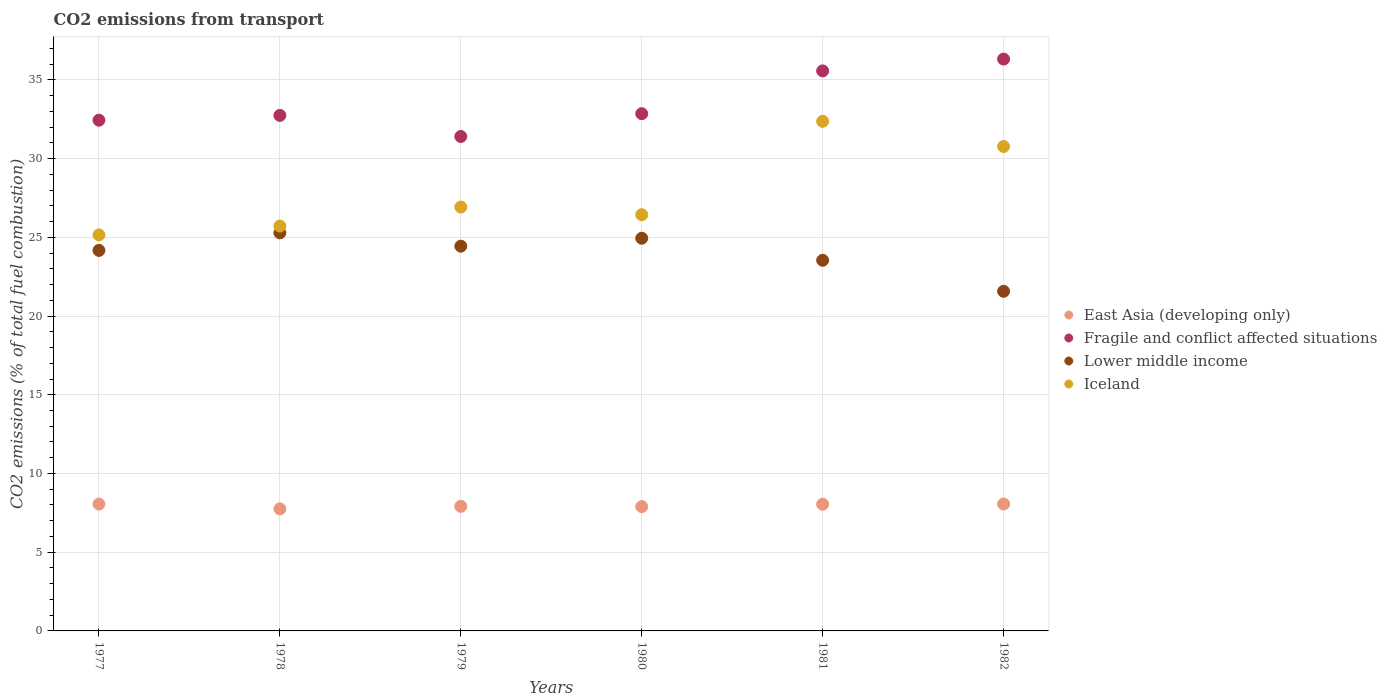How many different coloured dotlines are there?
Offer a very short reply. 4. What is the total CO2 emitted in Fragile and conflict affected situations in 1979?
Provide a succinct answer. 31.4. Across all years, what is the maximum total CO2 emitted in Lower middle income?
Offer a terse response. 25.28. Across all years, what is the minimum total CO2 emitted in Fragile and conflict affected situations?
Provide a short and direct response. 31.4. What is the total total CO2 emitted in East Asia (developing only) in the graph?
Provide a short and direct response. 47.73. What is the difference between the total CO2 emitted in Fragile and conflict affected situations in 1980 and that in 1981?
Give a very brief answer. -2.72. What is the difference between the total CO2 emitted in East Asia (developing only) in 1980 and the total CO2 emitted in Fragile and conflict affected situations in 1982?
Your answer should be very brief. -28.43. What is the average total CO2 emitted in East Asia (developing only) per year?
Provide a succinct answer. 7.95. In the year 1978, what is the difference between the total CO2 emitted in Lower middle income and total CO2 emitted in Iceland?
Your response must be concise. -0.43. In how many years, is the total CO2 emitted in Iceland greater than 34?
Your response must be concise. 0. What is the ratio of the total CO2 emitted in Iceland in 1978 to that in 1981?
Offer a very short reply. 0.79. Is the difference between the total CO2 emitted in Lower middle income in 1979 and 1982 greater than the difference between the total CO2 emitted in Iceland in 1979 and 1982?
Make the answer very short. Yes. What is the difference between the highest and the second highest total CO2 emitted in East Asia (developing only)?
Make the answer very short. 0. What is the difference between the highest and the lowest total CO2 emitted in Iceland?
Give a very brief answer. 7.22. Is the sum of the total CO2 emitted in Fragile and conflict affected situations in 1978 and 1979 greater than the maximum total CO2 emitted in Lower middle income across all years?
Offer a terse response. Yes. Does the total CO2 emitted in Fragile and conflict affected situations monotonically increase over the years?
Keep it short and to the point. No. Is the total CO2 emitted in Iceland strictly greater than the total CO2 emitted in Lower middle income over the years?
Your answer should be compact. Yes. What is the difference between two consecutive major ticks on the Y-axis?
Offer a terse response. 5. What is the title of the graph?
Provide a short and direct response. CO2 emissions from transport. Does "St. Lucia" appear as one of the legend labels in the graph?
Provide a succinct answer. No. What is the label or title of the X-axis?
Your response must be concise. Years. What is the label or title of the Y-axis?
Give a very brief answer. CO2 emissions (% of total fuel combustion). What is the CO2 emissions (% of total fuel combustion) in East Asia (developing only) in 1977?
Your response must be concise. 8.06. What is the CO2 emissions (% of total fuel combustion) of Fragile and conflict affected situations in 1977?
Provide a short and direct response. 32.44. What is the CO2 emissions (% of total fuel combustion) of Lower middle income in 1977?
Offer a very short reply. 24.17. What is the CO2 emissions (% of total fuel combustion) in Iceland in 1977?
Keep it short and to the point. 25.15. What is the CO2 emissions (% of total fuel combustion) of East Asia (developing only) in 1978?
Offer a very short reply. 7.75. What is the CO2 emissions (% of total fuel combustion) of Fragile and conflict affected situations in 1978?
Provide a succinct answer. 32.74. What is the CO2 emissions (% of total fuel combustion) in Lower middle income in 1978?
Offer a very short reply. 25.28. What is the CO2 emissions (% of total fuel combustion) in Iceland in 1978?
Offer a terse response. 25.71. What is the CO2 emissions (% of total fuel combustion) in East Asia (developing only) in 1979?
Keep it short and to the point. 7.91. What is the CO2 emissions (% of total fuel combustion) of Fragile and conflict affected situations in 1979?
Offer a very short reply. 31.4. What is the CO2 emissions (% of total fuel combustion) in Lower middle income in 1979?
Provide a succinct answer. 24.44. What is the CO2 emissions (% of total fuel combustion) in Iceland in 1979?
Provide a short and direct response. 26.92. What is the CO2 emissions (% of total fuel combustion) in East Asia (developing only) in 1980?
Keep it short and to the point. 7.9. What is the CO2 emissions (% of total fuel combustion) of Fragile and conflict affected situations in 1980?
Your answer should be very brief. 32.85. What is the CO2 emissions (% of total fuel combustion) in Lower middle income in 1980?
Provide a short and direct response. 24.94. What is the CO2 emissions (% of total fuel combustion) in Iceland in 1980?
Your response must be concise. 26.44. What is the CO2 emissions (% of total fuel combustion) of East Asia (developing only) in 1981?
Your response must be concise. 8.05. What is the CO2 emissions (% of total fuel combustion) in Fragile and conflict affected situations in 1981?
Ensure brevity in your answer.  35.57. What is the CO2 emissions (% of total fuel combustion) of Lower middle income in 1981?
Offer a very short reply. 23.54. What is the CO2 emissions (% of total fuel combustion) in Iceland in 1981?
Give a very brief answer. 32.37. What is the CO2 emissions (% of total fuel combustion) in East Asia (developing only) in 1982?
Your response must be concise. 8.06. What is the CO2 emissions (% of total fuel combustion) in Fragile and conflict affected situations in 1982?
Ensure brevity in your answer.  36.32. What is the CO2 emissions (% of total fuel combustion) of Lower middle income in 1982?
Offer a very short reply. 21.57. What is the CO2 emissions (% of total fuel combustion) of Iceland in 1982?
Ensure brevity in your answer.  30.77. Across all years, what is the maximum CO2 emissions (% of total fuel combustion) of East Asia (developing only)?
Ensure brevity in your answer.  8.06. Across all years, what is the maximum CO2 emissions (% of total fuel combustion) of Fragile and conflict affected situations?
Give a very brief answer. 36.32. Across all years, what is the maximum CO2 emissions (% of total fuel combustion) of Lower middle income?
Your response must be concise. 25.28. Across all years, what is the maximum CO2 emissions (% of total fuel combustion) in Iceland?
Keep it short and to the point. 32.37. Across all years, what is the minimum CO2 emissions (% of total fuel combustion) in East Asia (developing only)?
Provide a succinct answer. 7.75. Across all years, what is the minimum CO2 emissions (% of total fuel combustion) of Fragile and conflict affected situations?
Provide a short and direct response. 31.4. Across all years, what is the minimum CO2 emissions (% of total fuel combustion) of Lower middle income?
Keep it short and to the point. 21.57. Across all years, what is the minimum CO2 emissions (% of total fuel combustion) of Iceland?
Ensure brevity in your answer.  25.15. What is the total CO2 emissions (% of total fuel combustion) in East Asia (developing only) in the graph?
Your response must be concise. 47.73. What is the total CO2 emissions (% of total fuel combustion) of Fragile and conflict affected situations in the graph?
Provide a short and direct response. 201.33. What is the total CO2 emissions (% of total fuel combustion) in Lower middle income in the graph?
Your answer should be compact. 143.95. What is the total CO2 emissions (% of total fuel combustion) of Iceland in the graph?
Your answer should be compact. 167.37. What is the difference between the CO2 emissions (% of total fuel combustion) in East Asia (developing only) in 1977 and that in 1978?
Offer a terse response. 0.31. What is the difference between the CO2 emissions (% of total fuel combustion) of Fragile and conflict affected situations in 1977 and that in 1978?
Your answer should be compact. -0.3. What is the difference between the CO2 emissions (% of total fuel combustion) of Lower middle income in 1977 and that in 1978?
Provide a short and direct response. -1.11. What is the difference between the CO2 emissions (% of total fuel combustion) of Iceland in 1977 and that in 1978?
Offer a very short reply. -0.56. What is the difference between the CO2 emissions (% of total fuel combustion) of East Asia (developing only) in 1977 and that in 1979?
Your answer should be compact. 0.14. What is the difference between the CO2 emissions (% of total fuel combustion) in Fragile and conflict affected situations in 1977 and that in 1979?
Provide a short and direct response. 1.03. What is the difference between the CO2 emissions (% of total fuel combustion) of Lower middle income in 1977 and that in 1979?
Keep it short and to the point. -0.27. What is the difference between the CO2 emissions (% of total fuel combustion) of Iceland in 1977 and that in 1979?
Your answer should be compact. -1.77. What is the difference between the CO2 emissions (% of total fuel combustion) in East Asia (developing only) in 1977 and that in 1980?
Provide a short and direct response. 0.16. What is the difference between the CO2 emissions (% of total fuel combustion) of Fragile and conflict affected situations in 1977 and that in 1980?
Provide a succinct answer. -0.41. What is the difference between the CO2 emissions (% of total fuel combustion) in Lower middle income in 1977 and that in 1980?
Your response must be concise. -0.77. What is the difference between the CO2 emissions (% of total fuel combustion) of Iceland in 1977 and that in 1980?
Offer a very short reply. -1.28. What is the difference between the CO2 emissions (% of total fuel combustion) of East Asia (developing only) in 1977 and that in 1981?
Offer a terse response. 0.01. What is the difference between the CO2 emissions (% of total fuel combustion) of Fragile and conflict affected situations in 1977 and that in 1981?
Offer a terse response. -3.13. What is the difference between the CO2 emissions (% of total fuel combustion) of Lower middle income in 1977 and that in 1981?
Give a very brief answer. 0.63. What is the difference between the CO2 emissions (% of total fuel combustion) of Iceland in 1977 and that in 1981?
Keep it short and to the point. -7.22. What is the difference between the CO2 emissions (% of total fuel combustion) in East Asia (developing only) in 1977 and that in 1982?
Give a very brief answer. -0. What is the difference between the CO2 emissions (% of total fuel combustion) in Fragile and conflict affected situations in 1977 and that in 1982?
Your answer should be compact. -3.88. What is the difference between the CO2 emissions (% of total fuel combustion) in Lower middle income in 1977 and that in 1982?
Give a very brief answer. 2.6. What is the difference between the CO2 emissions (% of total fuel combustion) in Iceland in 1977 and that in 1982?
Your response must be concise. -5.62. What is the difference between the CO2 emissions (% of total fuel combustion) in East Asia (developing only) in 1978 and that in 1979?
Keep it short and to the point. -0.16. What is the difference between the CO2 emissions (% of total fuel combustion) in Fragile and conflict affected situations in 1978 and that in 1979?
Provide a succinct answer. 1.34. What is the difference between the CO2 emissions (% of total fuel combustion) of Lower middle income in 1978 and that in 1979?
Offer a terse response. 0.85. What is the difference between the CO2 emissions (% of total fuel combustion) of Iceland in 1978 and that in 1979?
Make the answer very short. -1.21. What is the difference between the CO2 emissions (% of total fuel combustion) of East Asia (developing only) in 1978 and that in 1980?
Your answer should be compact. -0.14. What is the difference between the CO2 emissions (% of total fuel combustion) of Fragile and conflict affected situations in 1978 and that in 1980?
Provide a succinct answer. -0.11. What is the difference between the CO2 emissions (% of total fuel combustion) in Lower middle income in 1978 and that in 1980?
Offer a terse response. 0.34. What is the difference between the CO2 emissions (% of total fuel combustion) of Iceland in 1978 and that in 1980?
Keep it short and to the point. -0.72. What is the difference between the CO2 emissions (% of total fuel combustion) in East Asia (developing only) in 1978 and that in 1981?
Your answer should be compact. -0.3. What is the difference between the CO2 emissions (% of total fuel combustion) in Fragile and conflict affected situations in 1978 and that in 1981?
Offer a terse response. -2.83. What is the difference between the CO2 emissions (% of total fuel combustion) in Lower middle income in 1978 and that in 1981?
Provide a succinct answer. 1.74. What is the difference between the CO2 emissions (% of total fuel combustion) of Iceland in 1978 and that in 1981?
Make the answer very short. -6.66. What is the difference between the CO2 emissions (% of total fuel combustion) of East Asia (developing only) in 1978 and that in 1982?
Your answer should be very brief. -0.31. What is the difference between the CO2 emissions (% of total fuel combustion) in Fragile and conflict affected situations in 1978 and that in 1982?
Offer a terse response. -3.58. What is the difference between the CO2 emissions (% of total fuel combustion) of Lower middle income in 1978 and that in 1982?
Your answer should be very brief. 3.71. What is the difference between the CO2 emissions (% of total fuel combustion) in Iceland in 1978 and that in 1982?
Your answer should be compact. -5.05. What is the difference between the CO2 emissions (% of total fuel combustion) of East Asia (developing only) in 1979 and that in 1980?
Offer a terse response. 0.02. What is the difference between the CO2 emissions (% of total fuel combustion) in Fragile and conflict affected situations in 1979 and that in 1980?
Your response must be concise. -1.45. What is the difference between the CO2 emissions (% of total fuel combustion) in Lower middle income in 1979 and that in 1980?
Your answer should be compact. -0.5. What is the difference between the CO2 emissions (% of total fuel combustion) in Iceland in 1979 and that in 1980?
Ensure brevity in your answer.  0.49. What is the difference between the CO2 emissions (% of total fuel combustion) in East Asia (developing only) in 1979 and that in 1981?
Your answer should be compact. -0.13. What is the difference between the CO2 emissions (% of total fuel combustion) of Fragile and conflict affected situations in 1979 and that in 1981?
Provide a succinct answer. -4.17. What is the difference between the CO2 emissions (% of total fuel combustion) in Lower middle income in 1979 and that in 1981?
Give a very brief answer. 0.9. What is the difference between the CO2 emissions (% of total fuel combustion) of Iceland in 1979 and that in 1981?
Your response must be concise. -5.45. What is the difference between the CO2 emissions (% of total fuel combustion) in East Asia (developing only) in 1979 and that in 1982?
Give a very brief answer. -0.15. What is the difference between the CO2 emissions (% of total fuel combustion) of Fragile and conflict affected situations in 1979 and that in 1982?
Your answer should be compact. -4.92. What is the difference between the CO2 emissions (% of total fuel combustion) of Lower middle income in 1979 and that in 1982?
Provide a succinct answer. 2.86. What is the difference between the CO2 emissions (% of total fuel combustion) in Iceland in 1979 and that in 1982?
Provide a short and direct response. -3.85. What is the difference between the CO2 emissions (% of total fuel combustion) of East Asia (developing only) in 1980 and that in 1981?
Provide a succinct answer. -0.15. What is the difference between the CO2 emissions (% of total fuel combustion) of Fragile and conflict affected situations in 1980 and that in 1981?
Offer a very short reply. -2.72. What is the difference between the CO2 emissions (% of total fuel combustion) of Lower middle income in 1980 and that in 1981?
Make the answer very short. 1.4. What is the difference between the CO2 emissions (% of total fuel combustion) in Iceland in 1980 and that in 1981?
Your response must be concise. -5.93. What is the difference between the CO2 emissions (% of total fuel combustion) of East Asia (developing only) in 1980 and that in 1982?
Keep it short and to the point. -0.17. What is the difference between the CO2 emissions (% of total fuel combustion) of Fragile and conflict affected situations in 1980 and that in 1982?
Provide a short and direct response. -3.47. What is the difference between the CO2 emissions (% of total fuel combustion) in Lower middle income in 1980 and that in 1982?
Offer a very short reply. 3.37. What is the difference between the CO2 emissions (% of total fuel combustion) of Iceland in 1980 and that in 1982?
Provide a short and direct response. -4.33. What is the difference between the CO2 emissions (% of total fuel combustion) of East Asia (developing only) in 1981 and that in 1982?
Keep it short and to the point. -0.01. What is the difference between the CO2 emissions (% of total fuel combustion) in Fragile and conflict affected situations in 1981 and that in 1982?
Offer a very short reply. -0.75. What is the difference between the CO2 emissions (% of total fuel combustion) in Lower middle income in 1981 and that in 1982?
Your response must be concise. 1.97. What is the difference between the CO2 emissions (% of total fuel combustion) of Iceland in 1981 and that in 1982?
Offer a very short reply. 1.6. What is the difference between the CO2 emissions (% of total fuel combustion) of East Asia (developing only) in 1977 and the CO2 emissions (% of total fuel combustion) of Fragile and conflict affected situations in 1978?
Your response must be concise. -24.69. What is the difference between the CO2 emissions (% of total fuel combustion) in East Asia (developing only) in 1977 and the CO2 emissions (% of total fuel combustion) in Lower middle income in 1978?
Give a very brief answer. -17.23. What is the difference between the CO2 emissions (% of total fuel combustion) of East Asia (developing only) in 1977 and the CO2 emissions (% of total fuel combustion) of Iceland in 1978?
Provide a short and direct response. -17.66. What is the difference between the CO2 emissions (% of total fuel combustion) of Fragile and conflict affected situations in 1977 and the CO2 emissions (% of total fuel combustion) of Lower middle income in 1978?
Your answer should be very brief. 7.16. What is the difference between the CO2 emissions (% of total fuel combustion) of Fragile and conflict affected situations in 1977 and the CO2 emissions (% of total fuel combustion) of Iceland in 1978?
Offer a terse response. 6.73. What is the difference between the CO2 emissions (% of total fuel combustion) of Lower middle income in 1977 and the CO2 emissions (% of total fuel combustion) of Iceland in 1978?
Your answer should be compact. -1.54. What is the difference between the CO2 emissions (% of total fuel combustion) of East Asia (developing only) in 1977 and the CO2 emissions (% of total fuel combustion) of Fragile and conflict affected situations in 1979?
Keep it short and to the point. -23.35. What is the difference between the CO2 emissions (% of total fuel combustion) of East Asia (developing only) in 1977 and the CO2 emissions (% of total fuel combustion) of Lower middle income in 1979?
Your answer should be very brief. -16.38. What is the difference between the CO2 emissions (% of total fuel combustion) in East Asia (developing only) in 1977 and the CO2 emissions (% of total fuel combustion) in Iceland in 1979?
Provide a short and direct response. -18.87. What is the difference between the CO2 emissions (% of total fuel combustion) in Fragile and conflict affected situations in 1977 and the CO2 emissions (% of total fuel combustion) in Lower middle income in 1979?
Provide a short and direct response. 8. What is the difference between the CO2 emissions (% of total fuel combustion) of Fragile and conflict affected situations in 1977 and the CO2 emissions (% of total fuel combustion) of Iceland in 1979?
Give a very brief answer. 5.52. What is the difference between the CO2 emissions (% of total fuel combustion) in Lower middle income in 1977 and the CO2 emissions (% of total fuel combustion) in Iceland in 1979?
Your answer should be compact. -2.75. What is the difference between the CO2 emissions (% of total fuel combustion) of East Asia (developing only) in 1977 and the CO2 emissions (% of total fuel combustion) of Fragile and conflict affected situations in 1980?
Ensure brevity in your answer.  -24.8. What is the difference between the CO2 emissions (% of total fuel combustion) in East Asia (developing only) in 1977 and the CO2 emissions (% of total fuel combustion) in Lower middle income in 1980?
Ensure brevity in your answer.  -16.88. What is the difference between the CO2 emissions (% of total fuel combustion) in East Asia (developing only) in 1977 and the CO2 emissions (% of total fuel combustion) in Iceland in 1980?
Give a very brief answer. -18.38. What is the difference between the CO2 emissions (% of total fuel combustion) in Fragile and conflict affected situations in 1977 and the CO2 emissions (% of total fuel combustion) in Lower middle income in 1980?
Make the answer very short. 7.5. What is the difference between the CO2 emissions (% of total fuel combustion) in Fragile and conflict affected situations in 1977 and the CO2 emissions (% of total fuel combustion) in Iceland in 1980?
Your answer should be compact. 6. What is the difference between the CO2 emissions (% of total fuel combustion) in Lower middle income in 1977 and the CO2 emissions (% of total fuel combustion) in Iceland in 1980?
Your response must be concise. -2.27. What is the difference between the CO2 emissions (% of total fuel combustion) in East Asia (developing only) in 1977 and the CO2 emissions (% of total fuel combustion) in Fragile and conflict affected situations in 1981?
Make the answer very short. -27.51. What is the difference between the CO2 emissions (% of total fuel combustion) in East Asia (developing only) in 1977 and the CO2 emissions (% of total fuel combustion) in Lower middle income in 1981?
Your answer should be compact. -15.48. What is the difference between the CO2 emissions (% of total fuel combustion) of East Asia (developing only) in 1977 and the CO2 emissions (% of total fuel combustion) of Iceland in 1981?
Ensure brevity in your answer.  -24.31. What is the difference between the CO2 emissions (% of total fuel combustion) in Fragile and conflict affected situations in 1977 and the CO2 emissions (% of total fuel combustion) in Lower middle income in 1981?
Your answer should be compact. 8.9. What is the difference between the CO2 emissions (% of total fuel combustion) of Fragile and conflict affected situations in 1977 and the CO2 emissions (% of total fuel combustion) of Iceland in 1981?
Your answer should be very brief. 0.07. What is the difference between the CO2 emissions (% of total fuel combustion) of Lower middle income in 1977 and the CO2 emissions (% of total fuel combustion) of Iceland in 1981?
Keep it short and to the point. -8.2. What is the difference between the CO2 emissions (% of total fuel combustion) in East Asia (developing only) in 1977 and the CO2 emissions (% of total fuel combustion) in Fragile and conflict affected situations in 1982?
Your answer should be very brief. -28.26. What is the difference between the CO2 emissions (% of total fuel combustion) of East Asia (developing only) in 1977 and the CO2 emissions (% of total fuel combustion) of Lower middle income in 1982?
Offer a terse response. -13.52. What is the difference between the CO2 emissions (% of total fuel combustion) in East Asia (developing only) in 1977 and the CO2 emissions (% of total fuel combustion) in Iceland in 1982?
Your answer should be compact. -22.71. What is the difference between the CO2 emissions (% of total fuel combustion) of Fragile and conflict affected situations in 1977 and the CO2 emissions (% of total fuel combustion) of Lower middle income in 1982?
Offer a terse response. 10.87. What is the difference between the CO2 emissions (% of total fuel combustion) in Fragile and conflict affected situations in 1977 and the CO2 emissions (% of total fuel combustion) in Iceland in 1982?
Provide a succinct answer. 1.67. What is the difference between the CO2 emissions (% of total fuel combustion) in Lower middle income in 1977 and the CO2 emissions (% of total fuel combustion) in Iceland in 1982?
Ensure brevity in your answer.  -6.6. What is the difference between the CO2 emissions (% of total fuel combustion) in East Asia (developing only) in 1978 and the CO2 emissions (% of total fuel combustion) in Fragile and conflict affected situations in 1979?
Give a very brief answer. -23.65. What is the difference between the CO2 emissions (% of total fuel combustion) in East Asia (developing only) in 1978 and the CO2 emissions (% of total fuel combustion) in Lower middle income in 1979?
Your answer should be very brief. -16.69. What is the difference between the CO2 emissions (% of total fuel combustion) of East Asia (developing only) in 1978 and the CO2 emissions (% of total fuel combustion) of Iceland in 1979?
Offer a terse response. -19.17. What is the difference between the CO2 emissions (% of total fuel combustion) of Fragile and conflict affected situations in 1978 and the CO2 emissions (% of total fuel combustion) of Lower middle income in 1979?
Ensure brevity in your answer.  8.31. What is the difference between the CO2 emissions (% of total fuel combustion) in Fragile and conflict affected situations in 1978 and the CO2 emissions (% of total fuel combustion) in Iceland in 1979?
Offer a terse response. 5.82. What is the difference between the CO2 emissions (% of total fuel combustion) in Lower middle income in 1978 and the CO2 emissions (% of total fuel combustion) in Iceland in 1979?
Make the answer very short. -1.64. What is the difference between the CO2 emissions (% of total fuel combustion) of East Asia (developing only) in 1978 and the CO2 emissions (% of total fuel combustion) of Fragile and conflict affected situations in 1980?
Make the answer very short. -25.1. What is the difference between the CO2 emissions (% of total fuel combustion) in East Asia (developing only) in 1978 and the CO2 emissions (% of total fuel combustion) in Lower middle income in 1980?
Make the answer very short. -17.19. What is the difference between the CO2 emissions (% of total fuel combustion) of East Asia (developing only) in 1978 and the CO2 emissions (% of total fuel combustion) of Iceland in 1980?
Offer a very short reply. -18.68. What is the difference between the CO2 emissions (% of total fuel combustion) in Fragile and conflict affected situations in 1978 and the CO2 emissions (% of total fuel combustion) in Lower middle income in 1980?
Provide a succinct answer. 7.8. What is the difference between the CO2 emissions (% of total fuel combustion) in Fragile and conflict affected situations in 1978 and the CO2 emissions (% of total fuel combustion) in Iceland in 1980?
Make the answer very short. 6.31. What is the difference between the CO2 emissions (% of total fuel combustion) in Lower middle income in 1978 and the CO2 emissions (% of total fuel combustion) in Iceland in 1980?
Your answer should be very brief. -1.15. What is the difference between the CO2 emissions (% of total fuel combustion) of East Asia (developing only) in 1978 and the CO2 emissions (% of total fuel combustion) of Fragile and conflict affected situations in 1981?
Your answer should be very brief. -27.82. What is the difference between the CO2 emissions (% of total fuel combustion) in East Asia (developing only) in 1978 and the CO2 emissions (% of total fuel combustion) in Lower middle income in 1981?
Give a very brief answer. -15.79. What is the difference between the CO2 emissions (% of total fuel combustion) in East Asia (developing only) in 1978 and the CO2 emissions (% of total fuel combustion) in Iceland in 1981?
Your answer should be compact. -24.62. What is the difference between the CO2 emissions (% of total fuel combustion) of Fragile and conflict affected situations in 1978 and the CO2 emissions (% of total fuel combustion) of Lower middle income in 1981?
Give a very brief answer. 9.2. What is the difference between the CO2 emissions (% of total fuel combustion) in Fragile and conflict affected situations in 1978 and the CO2 emissions (% of total fuel combustion) in Iceland in 1981?
Your answer should be very brief. 0.37. What is the difference between the CO2 emissions (% of total fuel combustion) of Lower middle income in 1978 and the CO2 emissions (% of total fuel combustion) of Iceland in 1981?
Ensure brevity in your answer.  -7.09. What is the difference between the CO2 emissions (% of total fuel combustion) of East Asia (developing only) in 1978 and the CO2 emissions (% of total fuel combustion) of Fragile and conflict affected situations in 1982?
Make the answer very short. -28.57. What is the difference between the CO2 emissions (% of total fuel combustion) of East Asia (developing only) in 1978 and the CO2 emissions (% of total fuel combustion) of Lower middle income in 1982?
Your answer should be very brief. -13.82. What is the difference between the CO2 emissions (% of total fuel combustion) in East Asia (developing only) in 1978 and the CO2 emissions (% of total fuel combustion) in Iceland in 1982?
Provide a succinct answer. -23.02. What is the difference between the CO2 emissions (% of total fuel combustion) of Fragile and conflict affected situations in 1978 and the CO2 emissions (% of total fuel combustion) of Lower middle income in 1982?
Give a very brief answer. 11.17. What is the difference between the CO2 emissions (% of total fuel combustion) of Fragile and conflict affected situations in 1978 and the CO2 emissions (% of total fuel combustion) of Iceland in 1982?
Provide a succinct answer. 1.97. What is the difference between the CO2 emissions (% of total fuel combustion) in Lower middle income in 1978 and the CO2 emissions (% of total fuel combustion) in Iceland in 1982?
Ensure brevity in your answer.  -5.49. What is the difference between the CO2 emissions (% of total fuel combustion) of East Asia (developing only) in 1979 and the CO2 emissions (% of total fuel combustion) of Fragile and conflict affected situations in 1980?
Offer a very short reply. -24.94. What is the difference between the CO2 emissions (% of total fuel combustion) of East Asia (developing only) in 1979 and the CO2 emissions (% of total fuel combustion) of Lower middle income in 1980?
Give a very brief answer. -17.03. What is the difference between the CO2 emissions (% of total fuel combustion) of East Asia (developing only) in 1979 and the CO2 emissions (% of total fuel combustion) of Iceland in 1980?
Give a very brief answer. -18.52. What is the difference between the CO2 emissions (% of total fuel combustion) of Fragile and conflict affected situations in 1979 and the CO2 emissions (% of total fuel combustion) of Lower middle income in 1980?
Offer a terse response. 6.46. What is the difference between the CO2 emissions (% of total fuel combustion) of Fragile and conflict affected situations in 1979 and the CO2 emissions (% of total fuel combustion) of Iceland in 1980?
Offer a very short reply. 4.97. What is the difference between the CO2 emissions (% of total fuel combustion) in Lower middle income in 1979 and the CO2 emissions (% of total fuel combustion) in Iceland in 1980?
Provide a succinct answer. -2. What is the difference between the CO2 emissions (% of total fuel combustion) in East Asia (developing only) in 1979 and the CO2 emissions (% of total fuel combustion) in Fragile and conflict affected situations in 1981?
Offer a terse response. -27.66. What is the difference between the CO2 emissions (% of total fuel combustion) in East Asia (developing only) in 1979 and the CO2 emissions (% of total fuel combustion) in Lower middle income in 1981?
Offer a very short reply. -15.63. What is the difference between the CO2 emissions (% of total fuel combustion) in East Asia (developing only) in 1979 and the CO2 emissions (% of total fuel combustion) in Iceland in 1981?
Keep it short and to the point. -24.46. What is the difference between the CO2 emissions (% of total fuel combustion) of Fragile and conflict affected situations in 1979 and the CO2 emissions (% of total fuel combustion) of Lower middle income in 1981?
Give a very brief answer. 7.86. What is the difference between the CO2 emissions (% of total fuel combustion) of Fragile and conflict affected situations in 1979 and the CO2 emissions (% of total fuel combustion) of Iceland in 1981?
Offer a terse response. -0.97. What is the difference between the CO2 emissions (% of total fuel combustion) in Lower middle income in 1979 and the CO2 emissions (% of total fuel combustion) in Iceland in 1981?
Your answer should be very brief. -7.93. What is the difference between the CO2 emissions (% of total fuel combustion) of East Asia (developing only) in 1979 and the CO2 emissions (% of total fuel combustion) of Fragile and conflict affected situations in 1982?
Make the answer very short. -28.41. What is the difference between the CO2 emissions (% of total fuel combustion) of East Asia (developing only) in 1979 and the CO2 emissions (% of total fuel combustion) of Lower middle income in 1982?
Provide a succinct answer. -13.66. What is the difference between the CO2 emissions (% of total fuel combustion) of East Asia (developing only) in 1979 and the CO2 emissions (% of total fuel combustion) of Iceland in 1982?
Your answer should be very brief. -22.86. What is the difference between the CO2 emissions (% of total fuel combustion) of Fragile and conflict affected situations in 1979 and the CO2 emissions (% of total fuel combustion) of Lower middle income in 1982?
Your answer should be compact. 9.83. What is the difference between the CO2 emissions (% of total fuel combustion) in Fragile and conflict affected situations in 1979 and the CO2 emissions (% of total fuel combustion) in Iceland in 1982?
Your answer should be very brief. 0.64. What is the difference between the CO2 emissions (% of total fuel combustion) of Lower middle income in 1979 and the CO2 emissions (% of total fuel combustion) of Iceland in 1982?
Ensure brevity in your answer.  -6.33. What is the difference between the CO2 emissions (% of total fuel combustion) of East Asia (developing only) in 1980 and the CO2 emissions (% of total fuel combustion) of Fragile and conflict affected situations in 1981?
Offer a terse response. -27.67. What is the difference between the CO2 emissions (% of total fuel combustion) in East Asia (developing only) in 1980 and the CO2 emissions (% of total fuel combustion) in Lower middle income in 1981?
Your answer should be very brief. -15.64. What is the difference between the CO2 emissions (% of total fuel combustion) in East Asia (developing only) in 1980 and the CO2 emissions (% of total fuel combustion) in Iceland in 1981?
Your answer should be compact. -24.47. What is the difference between the CO2 emissions (% of total fuel combustion) of Fragile and conflict affected situations in 1980 and the CO2 emissions (% of total fuel combustion) of Lower middle income in 1981?
Offer a terse response. 9.31. What is the difference between the CO2 emissions (% of total fuel combustion) of Fragile and conflict affected situations in 1980 and the CO2 emissions (% of total fuel combustion) of Iceland in 1981?
Offer a terse response. 0.48. What is the difference between the CO2 emissions (% of total fuel combustion) in Lower middle income in 1980 and the CO2 emissions (% of total fuel combustion) in Iceland in 1981?
Provide a succinct answer. -7.43. What is the difference between the CO2 emissions (% of total fuel combustion) of East Asia (developing only) in 1980 and the CO2 emissions (% of total fuel combustion) of Fragile and conflict affected situations in 1982?
Ensure brevity in your answer.  -28.43. What is the difference between the CO2 emissions (% of total fuel combustion) of East Asia (developing only) in 1980 and the CO2 emissions (% of total fuel combustion) of Lower middle income in 1982?
Provide a succinct answer. -13.68. What is the difference between the CO2 emissions (% of total fuel combustion) of East Asia (developing only) in 1980 and the CO2 emissions (% of total fuel combustion) of Iceland in 1982?
Your response must be concise. -22.87. What is the difference between the CO2 emissions (% of total fuel combustion) of Fragile and conflict affected situations in 1980 and the CO2 emissions (% of total fuel combustion) of Lower middle income in 1982?
Provide a short and direct response. 11.28. What is the difference between the CO2 emissions (% of total fuel combustion) of Fragile and conflict affected situations in 1980 and the CO2 emissions (% of total fuel combustion) of Iceland in 1982?
Your answer should be very brief. 2.08. What is the difference between the CO2 emissions (% of total fuel combustion) of Lower middle income in 1980 and the CO2 emissions (% of total fuel combustion) of Iceland in 1982?
Ensure brevity in your answer.  -5.83. What is the difference between the CO2 emissions (% of total fuel combustion) in East Asia (developing only) in 1981 and the CO2 emissions (% of total fuel combustion) in Fragile and conflict affected situations in 1982?
Ensure brevity in your answer.  -28.28. What is the difference between the CO2 emissions (% of total fuel combustion) of East Asia (developing only) in 1981 and the CO2 emissions (% of total fuel combustion) of Lower middle income in 1982?
Your answer should be compact. -13.53. What is the difference between the CO2 emissions (% of total fuel combustion) of East Asia (developing only) in 1981 and the CO2 emissions (% of total fuel combustion) of Iceland in 1982?
Ensure brevity in your answer.  -22.72. What is the difference between the CO2 emissions (% of total fuel combustion) of Fragile and conflict affected situations in 1981 and the CO2 emissions (% of total fuel combustion) of Lower middle income in 1982?
Offer a terse response. 14. What is the difference between the CO2 emissions (% of total fuel combustion) in Fragile and conflict affected situations in 1981 and the CO2 emissions (% of total fuel combustion) in Iceland in 1982?
Ensure brevity in your answer.  4.8. What is the difference between the CO2 emissions (% of total fuel combustion) in Lower middle income in 1981 and the CO2 emissions (% of total fuel combustion) in Iceland in 1982?
Keep it short and to the point. -7.23. What is the average CO2 emissions (% of total fuel combustion) in East Asia (developing only) per year?
Provide a succinct answer. 7.95. What is the average CO2 emissions (% of total fuel combustion) of Fragile and conflict affected situations per year?
Ensure brevity in your answer.  33.56. What is the average CO2 emissions (% of total fuel combustion) of Lower middle income per year?
Your answer should be very brief. 23.99. What is the average CO2 emissions (% of total fuel combustion) of Iceland per year?
Your answer should be compact. 27.89. In the year 1977, what is the difference between the CO2 emissions (% of total fuel combustion) of East Asia (developing only) and CO2 emissions (% of total fuel combustion) of Fragile and conflict affected situations?
Provide a short and direct response. -24.38. In the year 1977, what is the difference between the CO2 emissions (% of total fuel combustion) of East Asia (developing only) and CO2 emissions (% of total fuel combustion) of Lower middle income?
Your answer should be very brief. -16.11. In the year 1977, what is the difference between the CO2 emissions (% of total fuel combustion) in East Asia (developing only) and CO2 emissions (% of total fuel combustion) in Iceland?
Offer a terse response. -17.1. In the year 1977, what is the difference between the CO2 emissions (% of total fuel combustion) in Fragile and conflict affected situations and CO2 emissions (% of total fuel combustion) in Lower middle income?
Your answer should be very brief. 8.27. In the year 1977, what is the difference between the CO2 emissions (% of total fuel combustion) in Fragile and conflict affected situations and CO2 emissions (% of total fuel combustion) in Iceland?
Provide a short and direct response. 7.29. In the year 1977, what is the difference between the CO2 emissions (% of total fuel combustion) in Lower middle income and CO2 emissions (% of total fuel combustion) in Iceland?
Ensure brevity in your answer.  -0.98. In the year 1978, what is the difference between the CO2 emissions (% of total fuel combustion) of East Asia (developing only) and CO2 emissions (% of total fuel combustion) of Fragile and conflict affected situations?
Your response must be concise. -24.99. In the year 1978, what is the difference between the CO2 emissions (% of total fuel combustion) of East Asia (developing only) and CO2 emissions (% of total fuel combustion) of Lower middle income?
Give a very brief answer. -17.53. In the year 1978, what is the difference between the CO2 emissions (% of total fuel combustion) in East Asia (developing only) and CO2 emissions (% of total fuel combustion) in Iceland?
Your response must be concise. -17.96. In the year 1978, what is the difference between the CO2 emissions (% of total fuel combustion) of Fragile and conflict affected situations and CO2 emissions (% of total fuel combustion) of Lower middle income?
Ensure brevity in your answer.  7.46. In the year 1978, what is the difference between the CO2 emissions (% of total fuel combustion) of Fragile and conflict affected situations and CO2 emissions (% of total fuel combustion) of Iceland?
Your answer should be compact. 7.03. In the year 1978, what is the difference between the CO2 emissions (% of total fuel combustion) of Lower middle income and CO2 emissions (% of total fuel combustion) of Iceland?
Your answer should be very brief. -0.43. In the year 1979, what is the difference between the CO2 emissions (% of total fuel combustion) in East Asia (developing only) and CO2 emissions (% of total fuel combustion) in Fragile and conflict affected situations?
Ensure brevity in your answer.  -23.49. In the year 1979, what is the difference between the CO2 emissions (% of total fuel combustion) of East Asia (developing only) and CO2 emissions (% of total fuel combustion) of Lower middle income?
Your answer should be very brief. -16.52. In the year 1979, what is the difference between the CO2 emissions (% of total fuel combustion) of East Asia (developing only) and CO2 emissions (% of total fuel combustion) of Iceland?
Give a very brief answer. -19.01. In the year 1979, what is the difference between the CO2 emissions (% of total fuel combustion) in Fragile and conflict affected situations and CO2 emissions (% of total fuel combustion) in Lower middle income?
Make the answer very short. 6.97. In the year 1979, what is the difference between the CO2 emissions (% of total fuel combustion) in Fragile and conflict affected situations and CO2 emissions (% of total fuel combustion) in Iceland?
Your answer should be compact. 4.48. In the year 1979, what is the difference between the CO2 emissions (% of total fuel combustion) of Lower middle income and CO2 emissions (% of total fuel combustion) of Iceland?
Make the answer very short. -2.49. In the year 1980, what is the difference between the CO2 emissions (% of total fuel combustion) of East Asia (developing only) and CO2 emissions (% of total fuel combustion) of Fragile and conflict affected situations?
Offer a very short reply. -24.96. In the year 1980, what is the difference between the CO2 emissions (% of total fuel combustion) of East Asia (developing only) and CO2 emissions (% of total fuel combustion) of Lower middle income?
Your response must be concise. -17.05. In the year 1980, what is the difference between the CO2 emissions (% of total fuel combustion) of East Asia (developing only) and CO2 emissions (% of total fuel combustion) of Iceland?
Provide a succinct answer. -18.54. In the year 1980, what is the difference between the CO2 emissions (% of total fuel combustion) in Fragile and conflict affected situations and CO2 emissions (% of total fuel combustion) in Lower middle income?
Provide a short and direct response. 7.91. In the year 1980, what is the difference between the CO2 emissions (% of total fuel combustion) of Fragile and conflict affected situations and CO2 emissions (% of total fuel combustion) of Iceland?
Make the answer very short. 6.42. In the year 1980, what is the difference between the CO2 emissions (% of total fuel combustion) of Lower middle income and CO2 emissions (% of total fuel combustion) of Iceland?
Provide a short and direct response. -1.5. In the year 1981, what is the difference between the CO2 emissions (% of total fuel combustion) in East Asia (developing only) and CO2 emissions (% of total fuel combustion) in Fragile and conflict affected situations?
Your response must be concise. -27.52. In the year 1981, what is the difference between the CO2 emissions (% of total fuel combustion) in East Asia (developing only) and CO2 emissions (% of total fuel combustion) in Lower middle income?
Keep it short and to the point. -15.49. In the year 1981, what is the difference between the CO2 emissions (% of total fuel combustion) of East Asia (developing only) and CO2 emissions (% of total fuel combustion) of Iceland?
Your response must be concise. -24.32. In the year 1981, what is the difference between the CO2 emissions (% of total fuel combustion) in Fragile and conflict affected situations and CO2 emissions (% of total fuel combustion) in Lower middle income?
Give a very brief answer. 12.03. In the year 1981, what is the difference between the CO2 emissions (% of total fuel combustion) of Fragile and conflict affected situations and CO2 emissions (% of total fuel combustion) of Iceland?
Provide a short and direct response. 3.2. In the year 1981, what is the difference between the CO2 emissions (% of total fuel combustion) in Lower middle income and CO2 emissions (% of total fuel combustion) in Iceland?
Ensure brevity in your answer.  -8.83. In the year 1982, what is the difference between the CO2 emissions (% of total fuel combustion) in East Asia (developing only) and CO2 emissions (% of total fuel combustion) in Fragile and conflict affected situations?
Ensure brevity in your answer.  -28.26. In the year 1982, what is the difference between the CO2 emissions (% of total fuel combustion) of East Asia (developing only) and CO2 emissions (% of total fuel combustion) of Lower middle income?
Offer a terse response. -13.51. In the year 1982, what is the difference between the CO2 emissions (% of total fuel combustion) in East Asia (developing only) and CO2 emissions (% of total fuel combustion) in Iceland?
Offer a terse response. -22.71. In the year 1982, what is the difference between the CO2 emissions (% of total fuel combustion) in Fragile and conflict affected situations and CO2 emissions (% of total fuel combustion) in Lower middle income?
Your answer should be very brief. 14.75. In the year 1982, what is the difference between the CO2 emissions (% of total fuel combustion) of Fragile and conflict affected situations and CO2 emissions (% of total fuel combustion) of Iceland?
Provide a short and direct response. 5.55. In the year 1982, what is the difference between the CO2 emissions (% of total fuel combustion) in Lower middle income and CO2 emissions (% of total fuel combustion) in Iceland?
Ensure brevity in your answer.  -9.2. What is the ratio of the CO2 emissions (% of total fuel combustion) in East Asia (developing only) in 1977 to that in 1978?
Provide a short and direct response. 1.04. What is the ratio of the CO2 emissions (% of total fuel combustion) of Fragile and conflict affected situations in 1977 to that in 1978?
Offer a very short reply. 0.99. What is the ratio of the CO2 emissions (% of total fuel combustion) in Lower middle income in 1977 to that in 1978?
Give a very brief answer. 0.96. What is the ratio of the CO2 emissions (% of total fuel combustion) of Iceland in 1977 to that in 1978?
Offer a terse response. 0.98. What is the ratio of the CO2 emissions (% of total fuel combustion) in East Asia (developing only) in 1977 to that in 1979?
Keep it short and to the point. 1.02. What is the ratio of the CO2 emissions (% of total fuel combustion) of Fragile and conflict affected situations in 1977 to that in 1979?
Offer a very short reply. 1.03. What is the ratio of the CO2 emissions (% of total fuel combustion) in Iceland in 1977 to that in 1979?
Make the answer very short. 0.93. What is the ratio of the CO2 emissions (% of total fuel combustion) of East Asia (developing only) in 1977 to that in 1980?
Make the answer very short. 1.02. What is the ratio of the CO2 emissions (% of total fuel combustion) in Fragile and conflict affected situations in 1977 to that in 1980?
Provide a succinct answer. 0.99. What is the ratio of the CO2 emissions (% of total fuel combustion) of Lower middle income in 1977 to that in 1980?
Give a very brief answer. 0.97. What is the ratio of the CO2 emissions (% of total fuel combustion) in Iceland in 1977 to that in 1980?
Make the answer very short. 0.95. What is the ratio of the CO2 emissions (% of total fuel combustion) of East Asia (developing only) in 1977 to that in 1981?
Give a very brief answer. 1. What is the ratio of the CO2 emissions (% of total fuel combustion) in Fragile and conflict affected situations in 1977 to that in 1981?
Give a very brief answer. 0.91. What is the ratio of the CO2 emissions (% of total fuel combustion) of Lower middle income in 1977 to that in 1981?
Provide a succinct answer. 1.03. What is the ratio of the CO2 emissions (% of total fuel combustion) in Iceland in 1977 to that in 1981?
Make the answer very short. 0.78. What is the ratio of the CO2 emissions (% of total fuel combustion) in Fragile and conflict affected situations in 1977 to that in 1982?
Provide a short and direct response. 0.89. What is the ratio of the CO2 emissions (% of total fuel combustion) in Lower middle income in 1977 to that in 1982?
Make the answer very short. 1.12. What is the ratio of the CO2 emissions (% of total fuel combustion) in Iceland in 1977 to that in 1982?
Ensure brevity in your answer.  0.82. What is the ratio of the CO2 emissions (% of total fuel combustion) of East Asia (developing only) in 1978 to that in 1979?
Your response must be concise. 0.98. What is the ratio of the CO2 emissions (% of total fuel combustion) of Fragile and conflict affected situations in 1978 to that in 1979?
Your answer should be very brief. 1.04. What is the ratio of the CO2 emissions (% of total fuel combustion) in Lower middle income in 1978 to that in 1979?
Keep it short and to the point. 1.03. What is the ratio of the CO2 emissions (% of total fuel combustion) of Iceland in 1978 to that in 1979?
Your answer should be compact. 0.96. What is the ratio of the CO2 emissions (% of total fuel combustion) of East Asia (developing only) in 1978 to that in 1980?
Your answer should be compact. 0.98. What is the ratio of the CO2 emissions (% of total fuel combustion) of Fragile and conflict affected situations in 1978 to that in 1980?
Your response must be concise. 1. What is the ratio of the CO2 emissions (% of total fuel combustion) in Lower middle income in 1978 to that in 1980?
Ensure brevity in your answer.  1.01. What is the ratio of the CO2 emissions (% of total fuel combustion) of Iceland in 1978 to that in 1980?
Offer a very short reply. 0.97. What is the ratio of the CO2 emissions (% of total fuel combustion) in East Asia (developing only) in 1978 to that in 1981?
Your answer should be compact. 0.96. What is the ratio of the CO2 emissions (% of total fuel combustion) of Fragile and conflict affected situations in 1978 to that in 1981?
Your answer should be compact. 0.92. What is the ratio of the CO2 emissions (% of total fuel combustion) in Lower middle income in 1978 to that in 1981?
Provide a short and direct response. 1.07. What is the ratio of the CO2 emissions (% of total fuel combustion) in Iceland in 1978 to that in 1981?
Offer a very short reply. 0.79. What is the ratio of the CO2 emissions (% of total fuel combustion) of East Asia (developing only) in 1978 to that in 1982?
Your answer should be compact. 0.96. What is the ratio of the CO2 emissions (% of total fuel combustion) in Fragile and conflict affected situations in 1978 to that in 1982?
Make the answer very short. 0.9. What is the ratio of the CO2 emissions (% of total fuel combustion) of Lower middle income in 1978 to that in 1982?
Offer a terse response. 1.17. What is the ratio of the CO2 emissions (% of total fuel combustion) of Iceland in 1978 to that in 1982?
Ensure brevity in your answer.  0.84. What is the ratio of the CO2 emissions (% of total fuel combustion) of Fragile and conflict affected situations in 1979 to that in 1980?
Provide a succinct answer. 0.96. What is the ratio of the CO2 emissions (% of total fuel combustion) in Lower middle income in 1979 to that in 1980?
Keep it short and to the point. 0.98. What is the ratio of the CO2 emissions (% of total fuel combustion) of Iceland in 1979 to that in 1980?
Your answer should be compact. 1.02. What is the ratio of the CO2 emissions (% of total fuel combustion) of East Asia (developing only) in 1979 to that in 1981?
Offer a very short reply. 0.98. What is the ratio of the CO2 emissions (% of total fuel combustion) in Fragile and conflict affected situations in 1979 to that in 1981?
Make the answer very short. 0.88. What is the ratio of the CO2 emissions (% of total fuel combustion) in Lower middle income in 1979 to that in 1981?
Give a very brief answer. 1.04. What is the ratio of the CO2 emissions (% of total fuel combustion) of Iceland in 1979 to that in 1981?
Offer a terse response. 0.83. What is the ratio of the CO2 emissions (% of total fuel combustion) of East Asia (developing only) in 1979 to that in 1982?
Keep it short and to the point. 0.98. What is the ratio of the CO2 emissions (% of total fuel combustion) of Fragile and conflict affected situations in 1979 to that in 1982?
Offer a very short reply. 0.86. What is the ratio of the CO2 emissions (% of total fuel combustion) in Lower middle income in 1979 to that in 1982?
Offer a terse response. 1.13. What is the ratio of the CO2 emissions (% of total fuel combustion) of Iceland in 1979 to that in 1982?
Your response must be concise. 0.88. What is the ratio of the CO2 emissions (% of total fuel combustion) in East Asia (developing only) in 1980 to that in 1981?
Ensure brevity in your answer.  0.98. What is the ratio of the CO2 emissions (% of total fuel combustion) of Fragile and conflict affected situations in 1980 to that in 1981?
Your answer should be compact. 0.92. What is the ratio of the CO2 emissions (% of total fuel combustion) of Lower middle income in 1980 to that in 1981?
Make the answer very short. 1.06. What is the ratio of the CO2 emissions (% of total fuel combustion) in Iceland in 1980 to that in 1981?
Provide a short and direct response. 0.82. What is the ratio of the CO2 emissions (% of total fuel combustion) of East Asia (developing only) in 1980 to that in 1982?
Ensure brevity in your answer.  0.98. What is the ratio of the CO2 emissions (% of total fuel combustion) in Fragile and conflict affected situations in 1980 to that in 1982?
Provide a succinct answer. 0.9. What is the ratio of the CO2 emissions (% of total fuel combustion) in Lower middle income in 1980 to that in 1982?
Offer a terse response. 1.16. What is the ratio of the CO2 emissions (% of total fuel combustion) of Iceland in 1980 to that in 1982?
Your answer should be compact. 0.86. What is the ratio of the CO2 emissions (% of total fuel combustion) of East Asia (developing only) in 1981 to that in 1982?
Ensure brevity in your answer.  1. What is the ratio of the CO2 emissions (% of total fuel combustion) in Fragile and conflict affected situations in 1981 to that in 1982?
Provide a succinct answer. 0.98. What is the ratio of the CO2 emissions (% of total fuel combustion) of Lower middle income in 1981 to that in 1982?
Provide a succinct answer. 1.09. What is the ratio of the CO2 emissions (% of total fuel combustion) in Iceland in 1981 to that in 1982?
Ensure brevity in your answer.  1.05. What is the difference between the highest and the second highest CO2 emissions (% of total fuel combustion) in East Asia (developing only)?
Provide a short and direct response. 0. What is the difference between the highest and the second highest CO2 emissions (% of total fuel combustion) of Fragile and conflict affected situations?
Your answer should be very brief. 0.75. What is the difference between the highest and the second highest CO2 emissions (% of total fuel combustion) in Lower middle income?
Your answer should be very brief. 0.34. What is the difference between the highest and the second highest CO2 emissions (% of total fuel combustion) in Iceland?
Keep it short and to the point. 1.6. What is the difference between the highest and the lowest CO2 emissions (% of total fuel combustion) of East Asia (developing only)?
Ensure brevity in your answer.  0.31. What is the difference between the highest and the lowest CO2 emissions (% of total fuel combustion) in Fragile and conflict affected situations?
Ensure brevity in your answer.  4.92. What is the difference between the highest and the lowest CO2 emissions (% of total fuel combustion) in Lower middle income?
Your answer should be very brief. 3.71. What is the difference between the highest and the lowest CO2 emissions (% of total fuel combustion) in Iceland?
Offer a terse response. 7.22. 